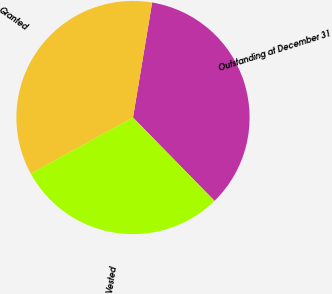Convert chart to OTSL. <chart><loc_0><loc_0><loc_500><loc_500><pie_chart><fcel>Outstanding at December 31<fcel>Granted<fcel>Vested<nl><fcel>35.05%<fcel>35.62%<fcel>29.34%<nl></chart> 